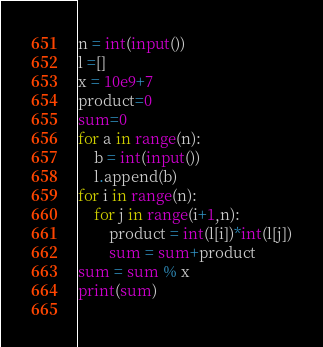<code> <loc_0><loc_0><loc_500><loc_500><_Python_>n = int(input())
l =[]
x = 10e9+7
product=0
sum=0
for a in range(n):
	b = int(input())
	l.append(b)
for i in range(n):
	for j in range(i+1,n):
		product = int(l[i])*int(l[j])
		sum = sum+product
sum = sum % x
print(sum)
		
</code> 